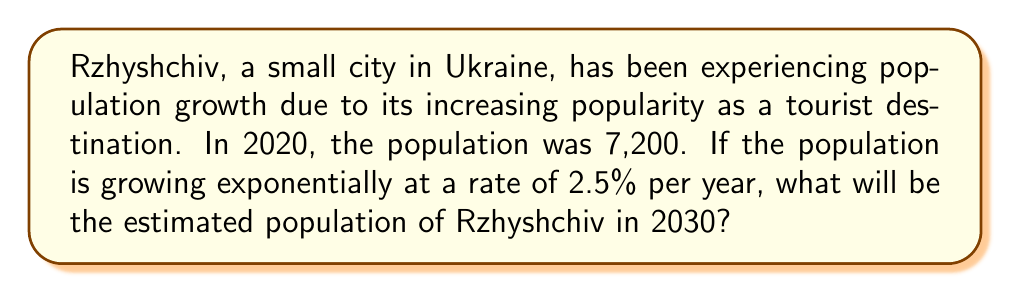Provide a solution to this math problem. To solve this problem, we'll use the exponential growth formula:

$$A = P(1 + r)^t$$

Where:
$A$ = final amount (population in 2030)
$P$ = initial amount (population in 2020)
$r$ = growth rate (as a decimal)
$t$ = time period (in years)

Given information:
$P = 7,200$
$r = 2.5\% = 0.025$
$t = 2030 - 2020 = 10$ years

Let's plug these values into the formula:

$$A = 7,200(1 + 0.025)^{10}$$

Now, let's calculate step-by-step:

1) First, calculate $(1 + 0.025)$:
   $1 + 0.025 = 1.025$

2) Now, raise this to the power of 10:
   $1.025^{10} \approx 1.2801$ (rounded to 4 decimal places)

3) Finally, multiply by the initial population:
   $7,200 \times 1.2801 \approx 9,216.72$

4) Round to the nearest whole number, as we're dealing with people:
   $9,217$ people

Therefore, the estimated population of Rzhyshchiv in 2030 will be 9,217 people.
Answer: 9,217 people 